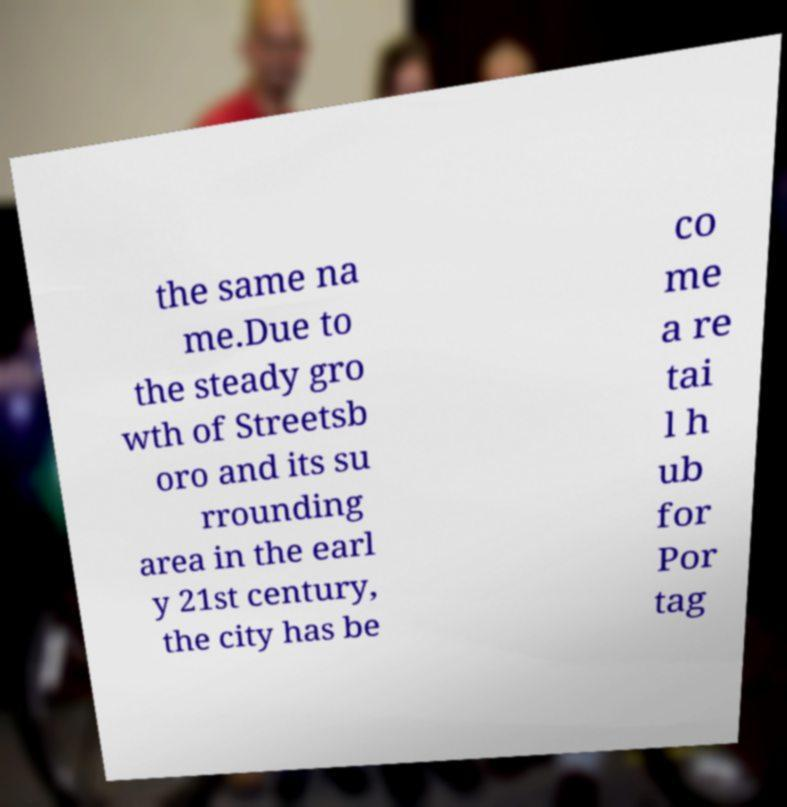I need the written content from this picture converted into text. Can you do that? the same na me.Due to the steady gro wth of Streetsb oro and its su rrounding area in the earl y 21st century, the city has be co me a re tai l h ub for Por tag 